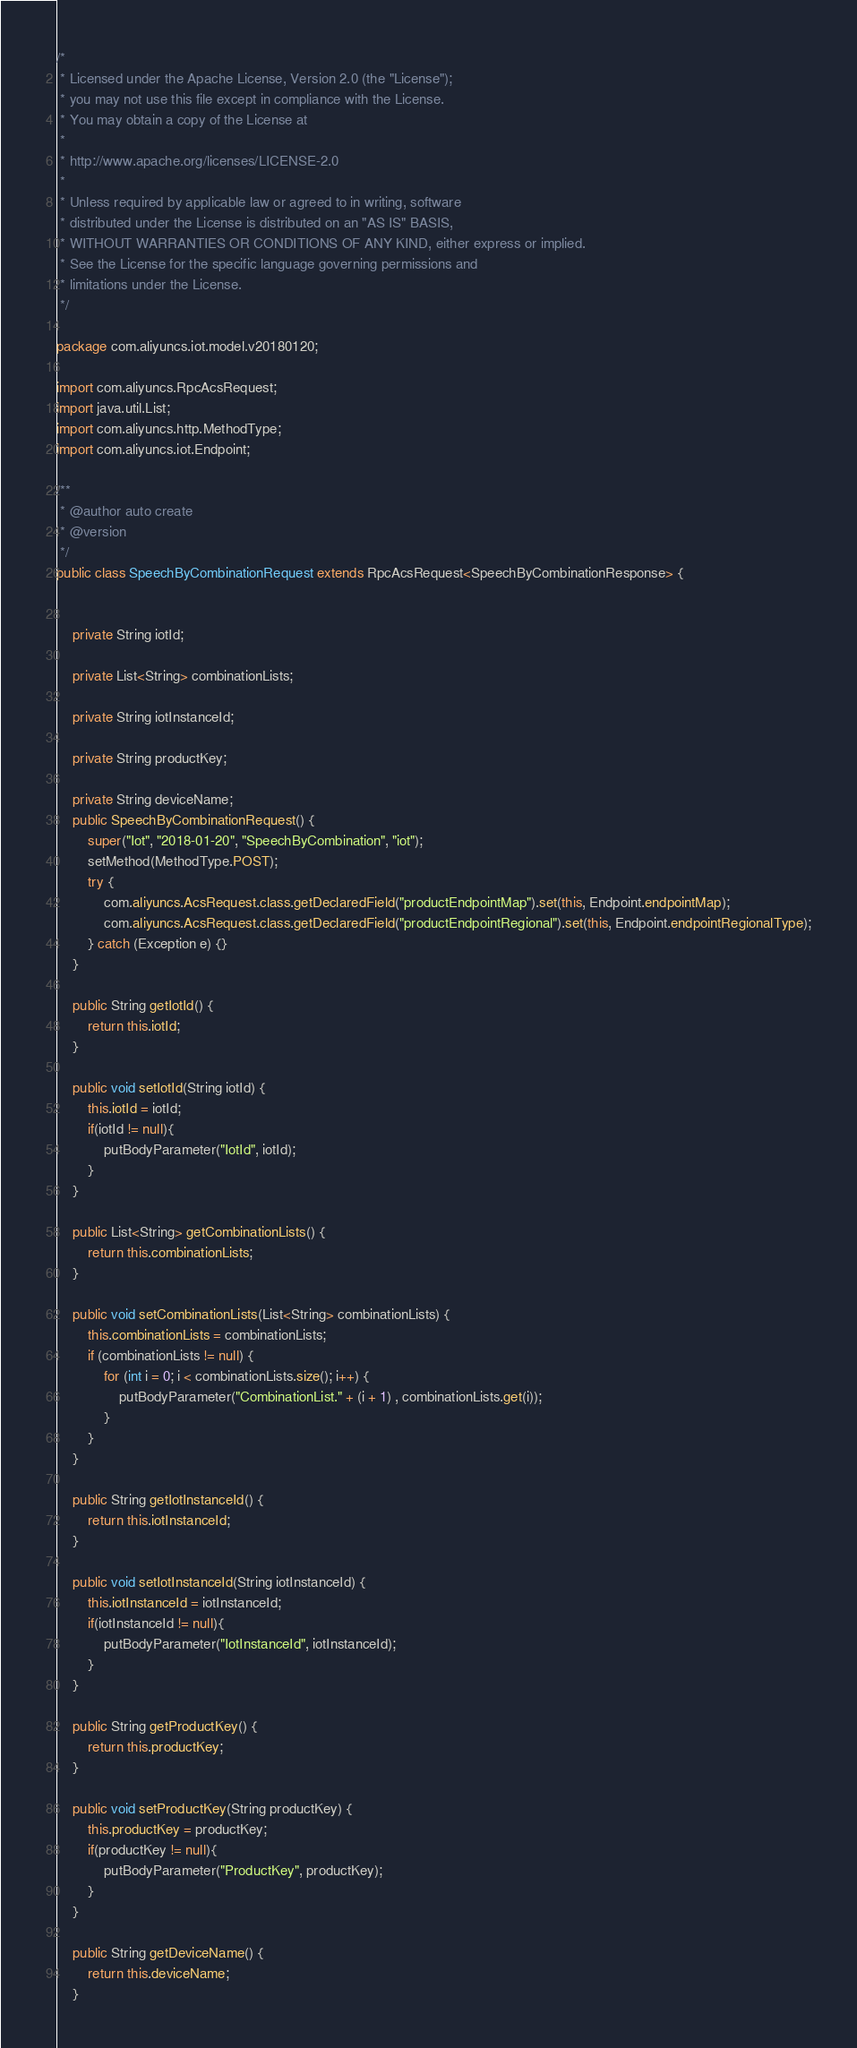Convert code to text. <code><loc_0><loc_0><loc_500><loc_500><_Java_>/*
 * Licensed under the Apache License, Version 2.0 (the "License");
 * you may not use this file except in compliance with the License.
 * You may obtain a copy of the License at
 *
 * http://www.apache.org/licenses/LICENSE-2.0
 *
 * Unless required by applicable law or agreed to in writing, software
 * distributed under the License is distributed on an "AS IS" BASIS,
 * WITHOUT WARRANTIES OR CONDITIONS OF ANY KIND, either express or implied.
 * See the License for the specific language governing permissions and
 * limitations under the License.
 */

package com.aliyuncs.iot.model.v20180120;

import com.aliyuncs.RpcAcsRequest;
import java.util.List;
import com.aliyuncs.http.MethodType;
import com.aliyuncs.iot.Endpoint;

/**
 * @author auto create
 * @version 
 */
public class SpeechByCombinationRequest extends RpcAcsRequest<SpeechByCombinationResponse> {
	   

	private String iotId;

	private List<String> combinationLists;

	private String iotInstanceId;

	private String productKey;

	private String deviceName;
	public SpeechByCombinationRequest() {
		super("Iot", "2018-01-20", "SpeechByCombination", "iot");
		setMethod(MethodType.POST);
		try {
			com.aliyuncs.AcsRequest.class.getDeclaredField("productEndpointMap").set(this, Endpoint.endpointMap);
			com.aliyuncs.AcsRequest.class.getDeclaredField("productEndpointRegional").set(this, Endpoint.endpointRegionalType);
		} catch (Exception e) {}
	}

	public String getIotId() {
		return this.iotId;
	}

	public void setIotId(String iotId) {
		this.iotId = iotId;
		if(iotId != null){
			putBodyParameter("IotId", iotId);
		}
	}

	public List<String> getCombinationLists() {
		return this.combinationLists;
	}

	public void setCombinationLists(List<String> combinationLists) {
		this.combinationLists = combinationLists;	
		if (combinationLists != null) {
			for (int i = 0; i < combinationLists.size(); i++) {
				putBodyParameter("CombinationList." + (i + 1) , combinationLists.get(i));
			}
		}	
	}

	public String getIotInstanceId() {
		return this.iotInstanceId;
	}

	public void setIotInstanceId(String iotInstanceId) {
		this.iotInstanceId = iotInstanceId;
		if(iotInstanceId != null){
			putBodyParameter("IotInstanceId", iotInstanceId);
		}
	}

	public String getProductKey() {
		return this.productKey;
	}

	public void setProductKey(String productKey) {
		this.productKey = productKey;
		if(productKey != null){
			putBodyParameter("ProductKey", productKey);
		}
	}

	public String getDeviceName() {
		return this.deviceName;
	}
</code> 